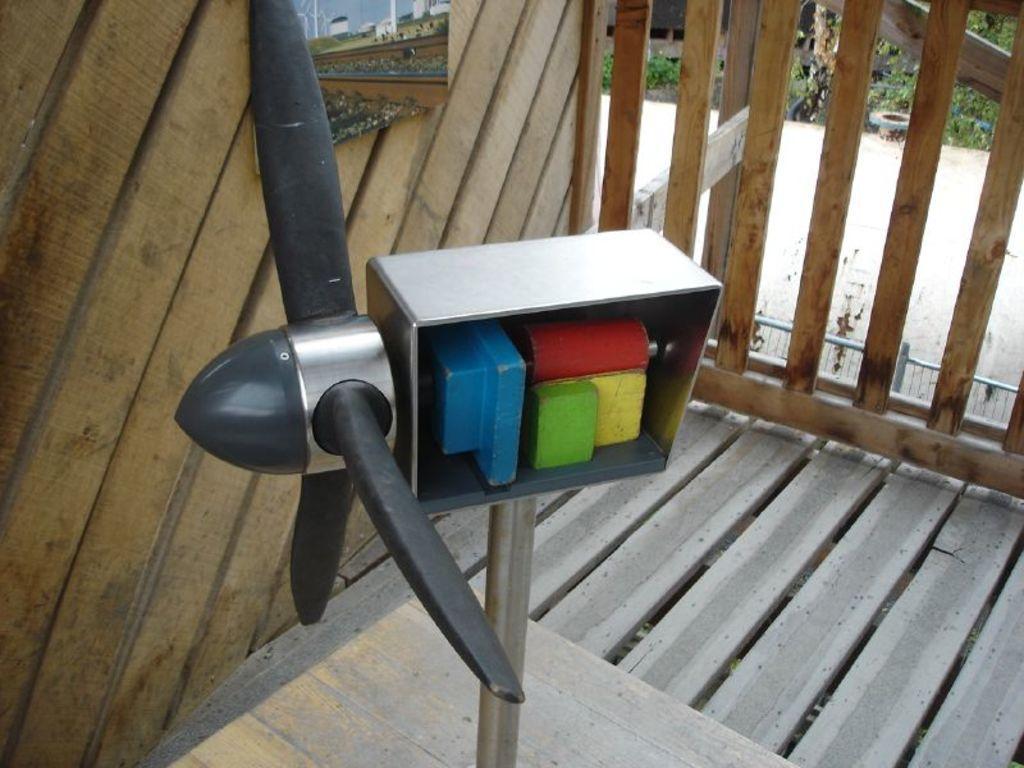In one or two sentences, can you explain what this image depicts? In this image I can see the fan and I can see few colorful objects in the iron box. In the background I can see the board attached to the wooden wall and I can see few plants in green color. 